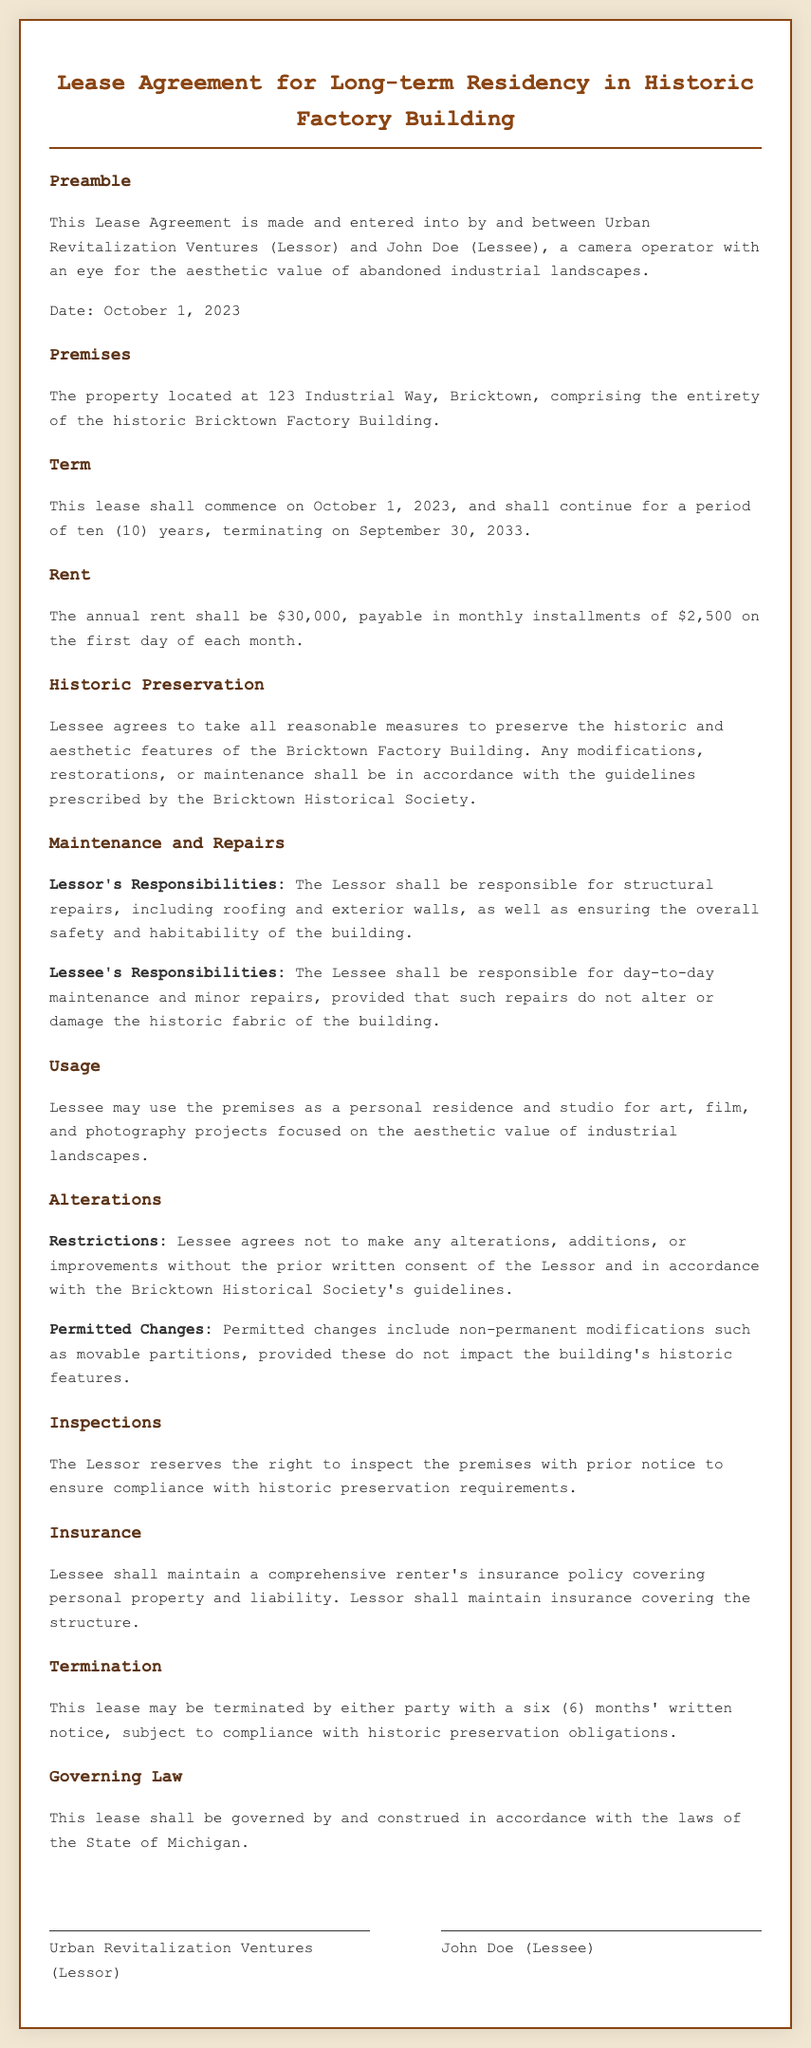what is the name of the Lessor? The name of the Lessor is stated in the preamble of the document as Urban Revitalization Ventures.
Answer: Urban Revitalization Ventures what is the annual rent amount? The document specifies the annual rent amount as $30,000.
Answer: $30,000 when does the lease term start? The lease term start date is mentioned in the "Term" section as October 1, 2023.
Answer: October 1, 2023 what is the duration of the lease? The lease duration is specified in the "Term" section as ten (10) years.
Answer: ten (10) years who is responsible for structural repairs? According to the "Maintenance and Repairs" section, the Lessor is responsible for structural repairs.
Answer: Lessor can the Lessee make alterations without consent? The document states that the Lessee cannot make alterations without prior written consent from the Lessor.
Answer: No what type of insurance must the Lessee have? The Lessee must maintain a comprehensive renter's insurance policy as stated in the "Insurance" section.
Answer: comprehensive renter's insurance how long is the notice period for lease termination? The notice period for termination is stated as six (6) months in the "Termination" section.
Answer: six (6) months what guidelines must be followed for modifications? Modifications must be in accordance with the guidelines prescribed by the Bricktown Historical Society.
Answer: Bricktown Historical Society what is the purpose of the Lessee's use of the premises? The Lessee may use the premises for personal residence and studio for art, film, and photography projects.
Answer: personal residence and studio 